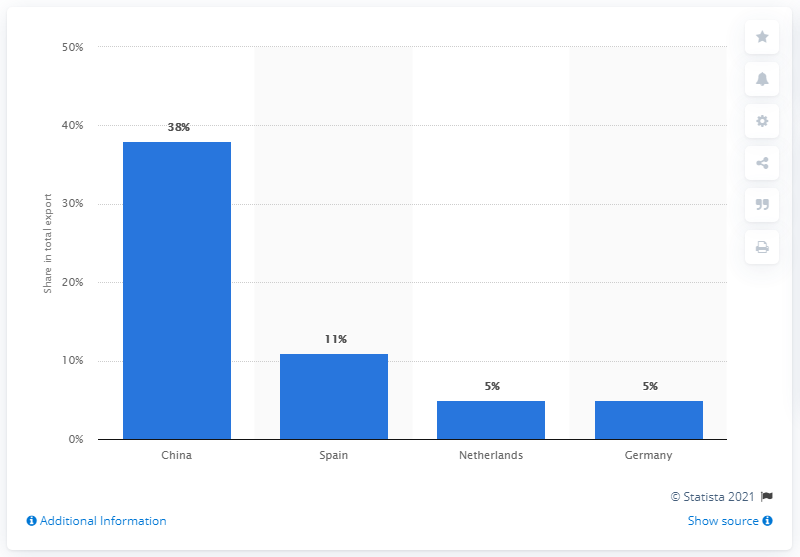Mention a couple of crucial points in this snapshot. In 2019, Cuba's most important export partner was China. 